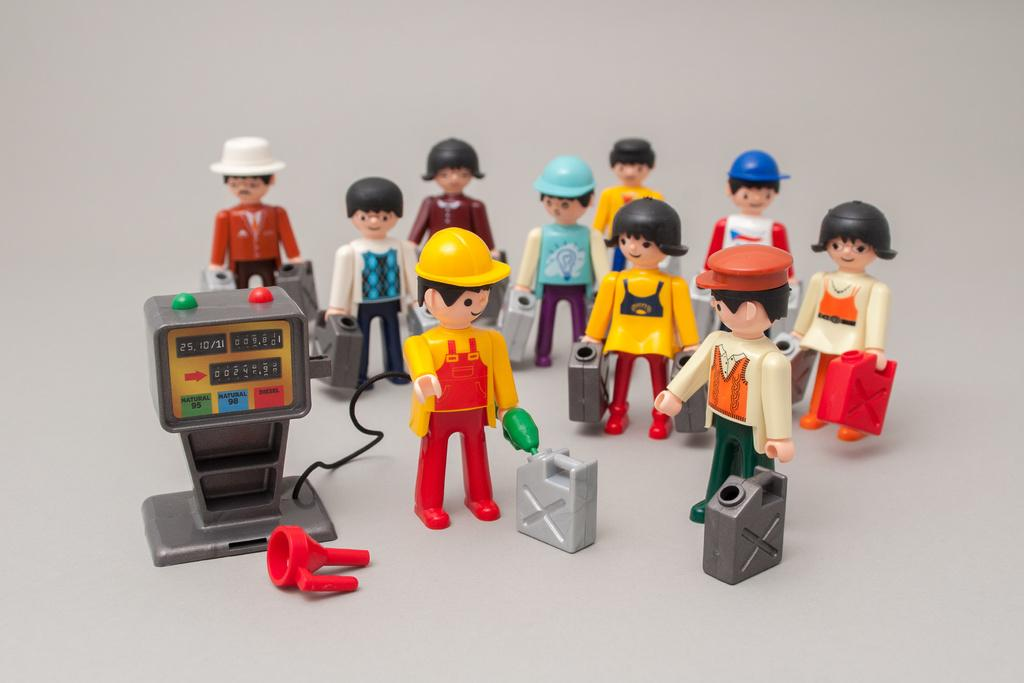What objects are present in the image? There are toys in the image. What is the color of the surface on which the toys are placed? The toys are on a white surface. What type of punishment is being administered to the toys in the image? There is no punishment being administered to the toys in the image; they are simply placed on a white surface. What kind of guitar can be seen in the image? There is no guitar present in the image. 